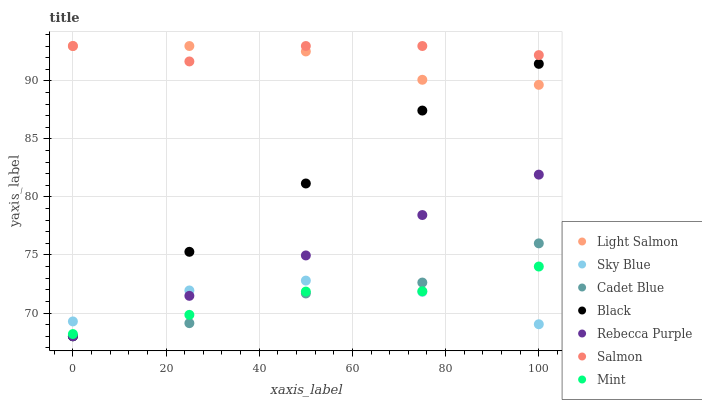Does Mint have the minimum area under the curve?
Answer yes or no. Yes. Does Salmon have the maximum area under the curve?
Answer yes or no. Yes. Does Cadet Blue have the minimum area under the curve?
Answer yes or no. No. Does Cadet Blue have the maximum area under the curve?
Answer yes or no. No. Is Rebecca Purple the smoothest?
Answer yes or no. Yes. Is Cadet Blue the roughest?
Answer yes or no. Yes. Is Salmon the smoothest?
Answer yes or no. No. Is Salmon the roughest?
Answer yes or no. No. Does Cadet Blue have the lowest value?
Answer yes or no. Yes. Does Salmon have the lowest value?
Answer yes or no. No. Does Salmon have the highest value?
Answer yes or no. Yes. Does Cadet Blue have the highest value?
Answer yes or no. No. Is Cadet Blue less than Light Salmon?
Answer yes or no. Yes. Is Light Salmon greater than Sky Blue?
Answer yes or no. Yes. Does Black intersect Sky Blue?
Answer yes or no. Yes. Is Black less than Sky Blue?
Answer yes or no. No. Is Black greater than Sky Blue?
Answer yes or no. No. Does Cadet Blue intersect Light Salmon?
Answer yes or no. No. 